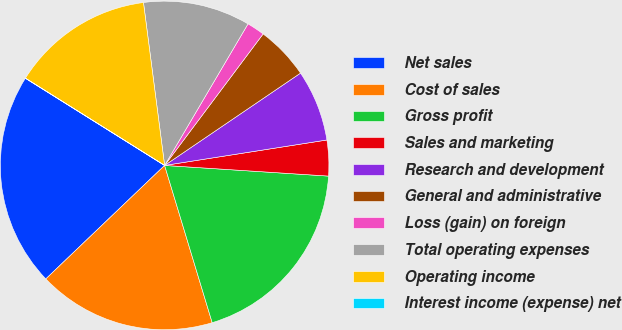Convert chart. <chart><loc_0><loc_0><loc_500><loc_500><pie_chart><fcel>Net sales<fcel>Cost of sales<fcel>Gross profit<fcel>Sales and marketing<fcel>Research and development<fcel>General and administrative<fcel>Loss (gain) on foreign<fcel>Total operating expenses<fcel>Operating income<fcel>Interest income (expense) net<nl><fcel>21.04%<fcel>17.54%<fcel>19.29%<fcel>3.51%<fcel>7.02%<fcel>5.27%<fcel>1.76%<fcel>10.53%<fcel>14.03%<fcel>0.01%<nl></chart> 